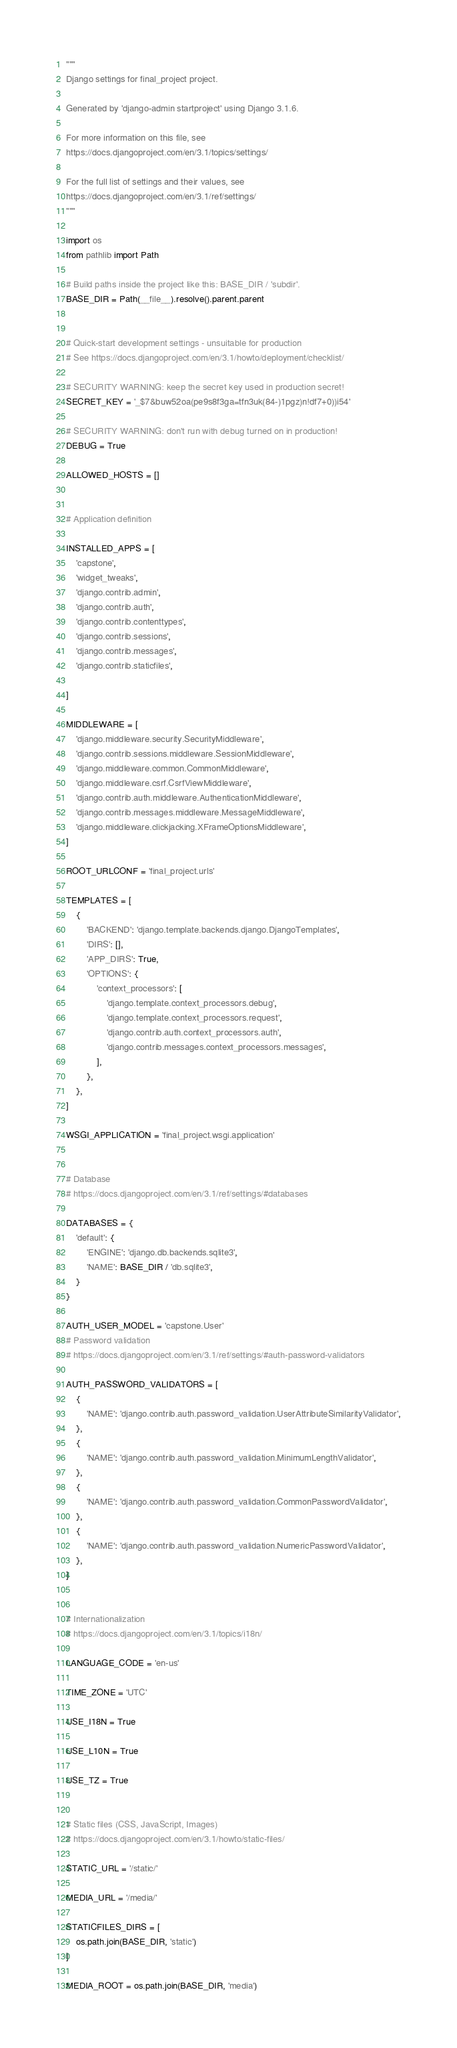<code> <loc_0><loc_0><loc_500><loc_500><_Python_>"""
Django settings for final_project project.

Generated by 'django-admin startproject' using Django 3.1.6.

For more information on this file, see
https://docs.djangoproject.com/en/3.1/topics/settings/

For the full list of settings and their values, see
https://docs.djangoproject.com/en/3.1/ref/settings/
"""

import os
from pathlib import Path

# Build paths inside the project like this: BASE_DIR / 'subdir'.
BASE_DIR = Path(__file__).resolve().parent.parent


# Quick-start development settings - unsuitable for production
# See https://docs.djangoproject.com/en/3.1/howto/deployment/checklist/

# SECURITY WARNING: keep the secret key used in production secret!
SECRET_KEY = '_$7&buw52oa(pe9s8f3ga=tfn3uk(84-)1pgz)n!df7+0))i54'

# SECURITY WARNING: don't run with debug turned on in production!
DEBUG = True

ALLOWED_HOSTS = []


# Application definition

INSTALLED_APPS = [
    'capstone',
    'widget_tweaks',
    'django.contrib.admin',
    'django.contrib.auth',
    'django.contrib.contenttypes',
    'django.contrib.sessions',
    'django.contrib.messages',
    'django.contrib.staticfiles',
    
]

MIDDLEWARE = [
    'django.middleware.security.SecurityMiddleware',
    'django.contrib.sessions.middleware.SessionMiddleware',
    'django.middleware.common.CommonMiddleware',
    'django.middleware.csrf.CsrfViewMiddleware',
    'django.contrib.auth.middleware.AuthenticationMiddleware',
    'django.contrib.messages.middleware.MessageMiddleware',
    'django.middleware.clickjacking.XFrameOptionsMiddleware',
]

ROOT_URLCONF = 'final_project.urls'

TEMPLATES = [
    {
        'BACKEND': 'django.template.backends.django.DjangoTemplates',
        'DIRS': [],
        'APP_DIRS': True,
        'OPTIONS': {
            'context_processors': [
                'django.template.context_processors.debug',
                'django.template.context_processors.request',
                'django.contrib.auth.context_processors.auth',
                'django.contrib.messages.context_processors.messages',
            ],
        },
    },
]

WSGI_APPLICATION = 'final_project.wsgi.application'


# Database
# https://docs.djangoproject.com/en/3.1/ref/settings/#databases

DATABASES = {
    'default': {
        'ENGINE': 'django.db.backends.sqlite3',
        'NAME': BASE_DIR / 'db.sqlite3',
    }
}

AUTH_USER_MODEL = 'capstone.User'
# Password validation
# https://docs.djangoproject.com/en/3.1/ref/settings/#auth-password-validators

AUTH_PASSWORD_VALIDATORS = [
    {
        'NAME': 'django.contrib.auth.password_validation.UserAttributeSimilarityValidator',
    },
    {
        'NAME': 'django.contrib.auth.password_validation.MinimumLengthValidator',
    },
    {
        'NAME': 'django.contrib.auth.password_validation.CommonPasswordValidator',
    },
    {
        'NAME': 'django.contrib.auth.password_validation.NumericPasswordValidator',
    },
]


# Internationalization
# https://docs.djangoproject.com/en/3.1/topics/i18n/

LANGUAGE_CODE = 'en-us'

TIME_ZONE = 'UTC'

USE_I18N = True

USE_L10N = True

USE_TZ = True


# Static files (CSS, JavaScript, Images)
# https://docs.djangoproject.com/en/3.1/howto/static-files/

STATIC_URL = '/static/'

MEDIA_URL = '/media/'

STATICFILES_DIRS = [
    os.path.join(BASE_DIR, 'static')
]

MEDIA_ROOT = os.path.join(BASE_DIR, 'media')
</code> 